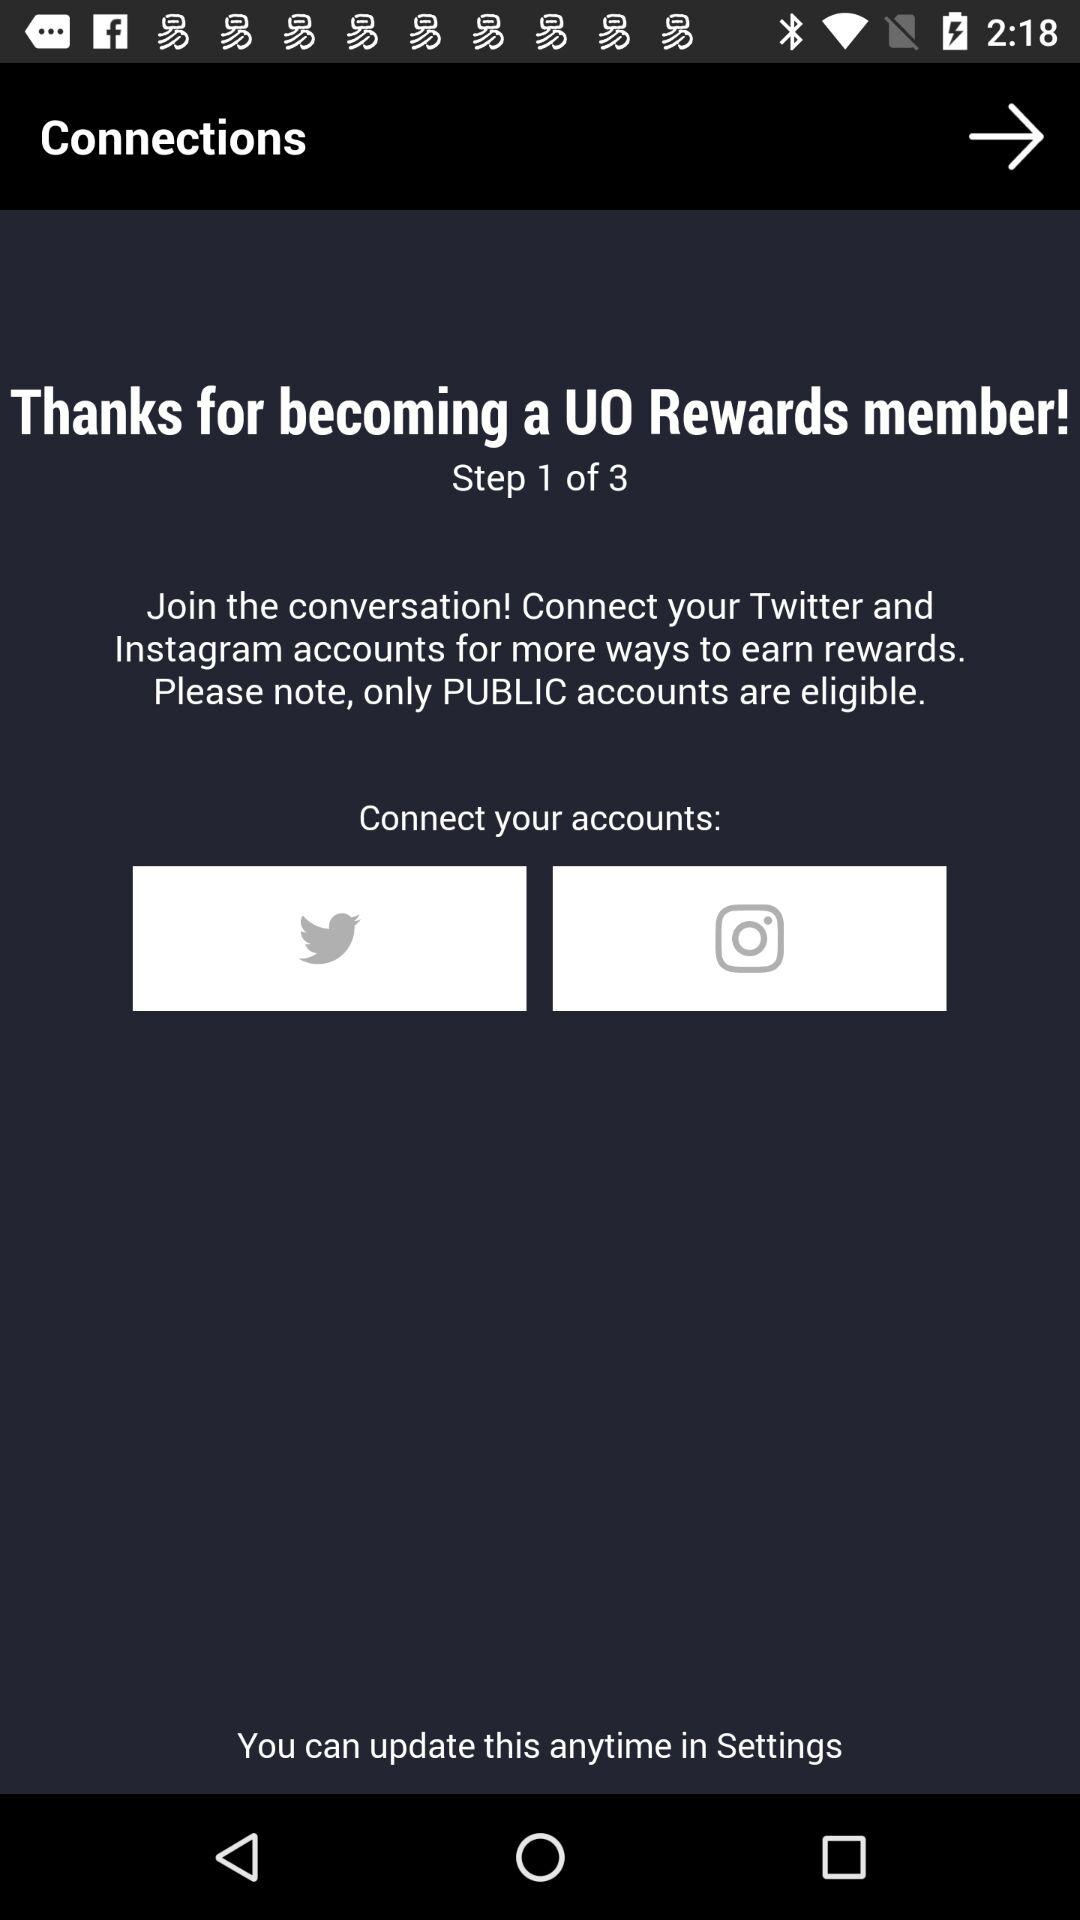What are the eligible accounts? It is only public accounts. 